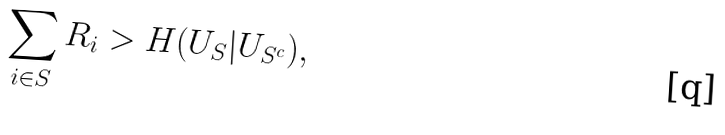Convert formula to latex. <formula><loc_0><loc_0><loc_500><loc_500>\sum _ { i \in S } R _ { i } > H ( U _ { S } | U _ { S ^ { c } } ) ,</formula> 